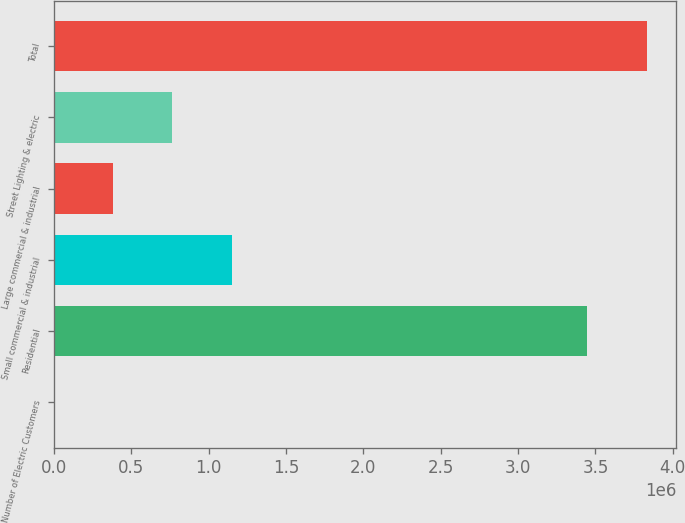<chart> <loc_0><loc_0><loc_500><loc_500><bar_chart><fcel>Number of Electric Customers<fcel>Residential<fcel>Small commercial & industrial<fcel>Large commercial & industrial<fcel>Street Lighting & electric<fcel>Total<nl><fcel>2011<fcel>3.44848e+06<fcel>1.14775e+06<fcel>383923<fcel>765836<fcel>3.83039e+06<nl></chart> 